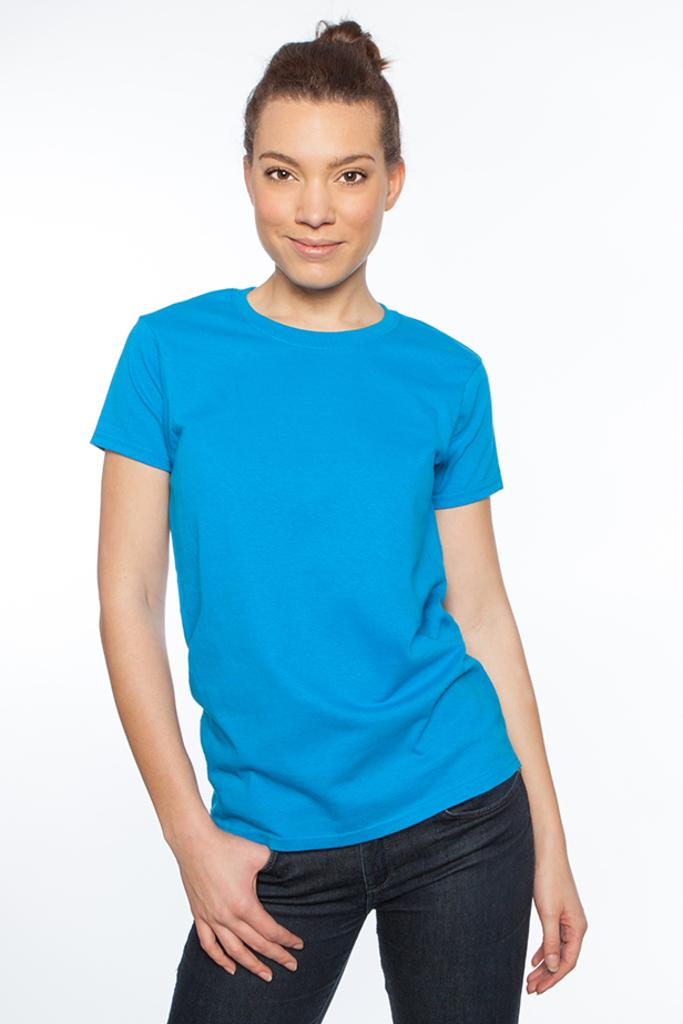Who is the main subject in the image? There is a woman in the image. What is the woman doing in the image? The woman is standing. What color is the woman's shirt in the image? The woman is wearing a blue shirt. What color are the woman's pants in the image? The woman is wearing black jeans. What color is the background of the image? The background of the image is white. How does the woman use glue in the image? There is no glue present in the image, and therefore no such activity can be observed. 